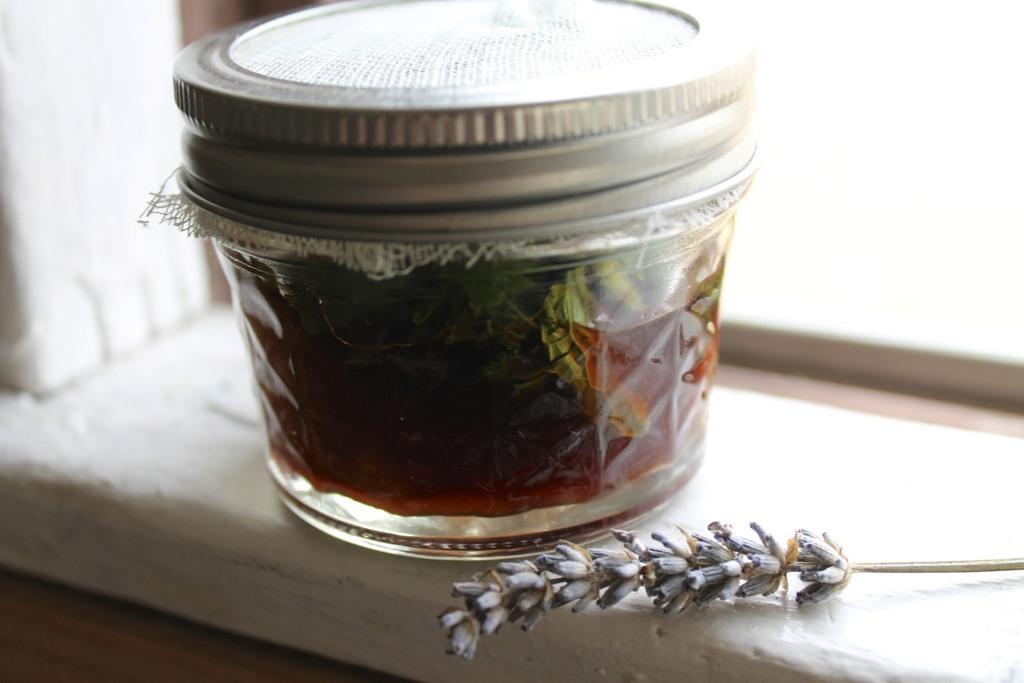In one or two sentences, can you explain what this image depicts? In this picture, we can see ajar with some liquid, and some leaves in it, we can see some dry object and the jar on the white color surface. 